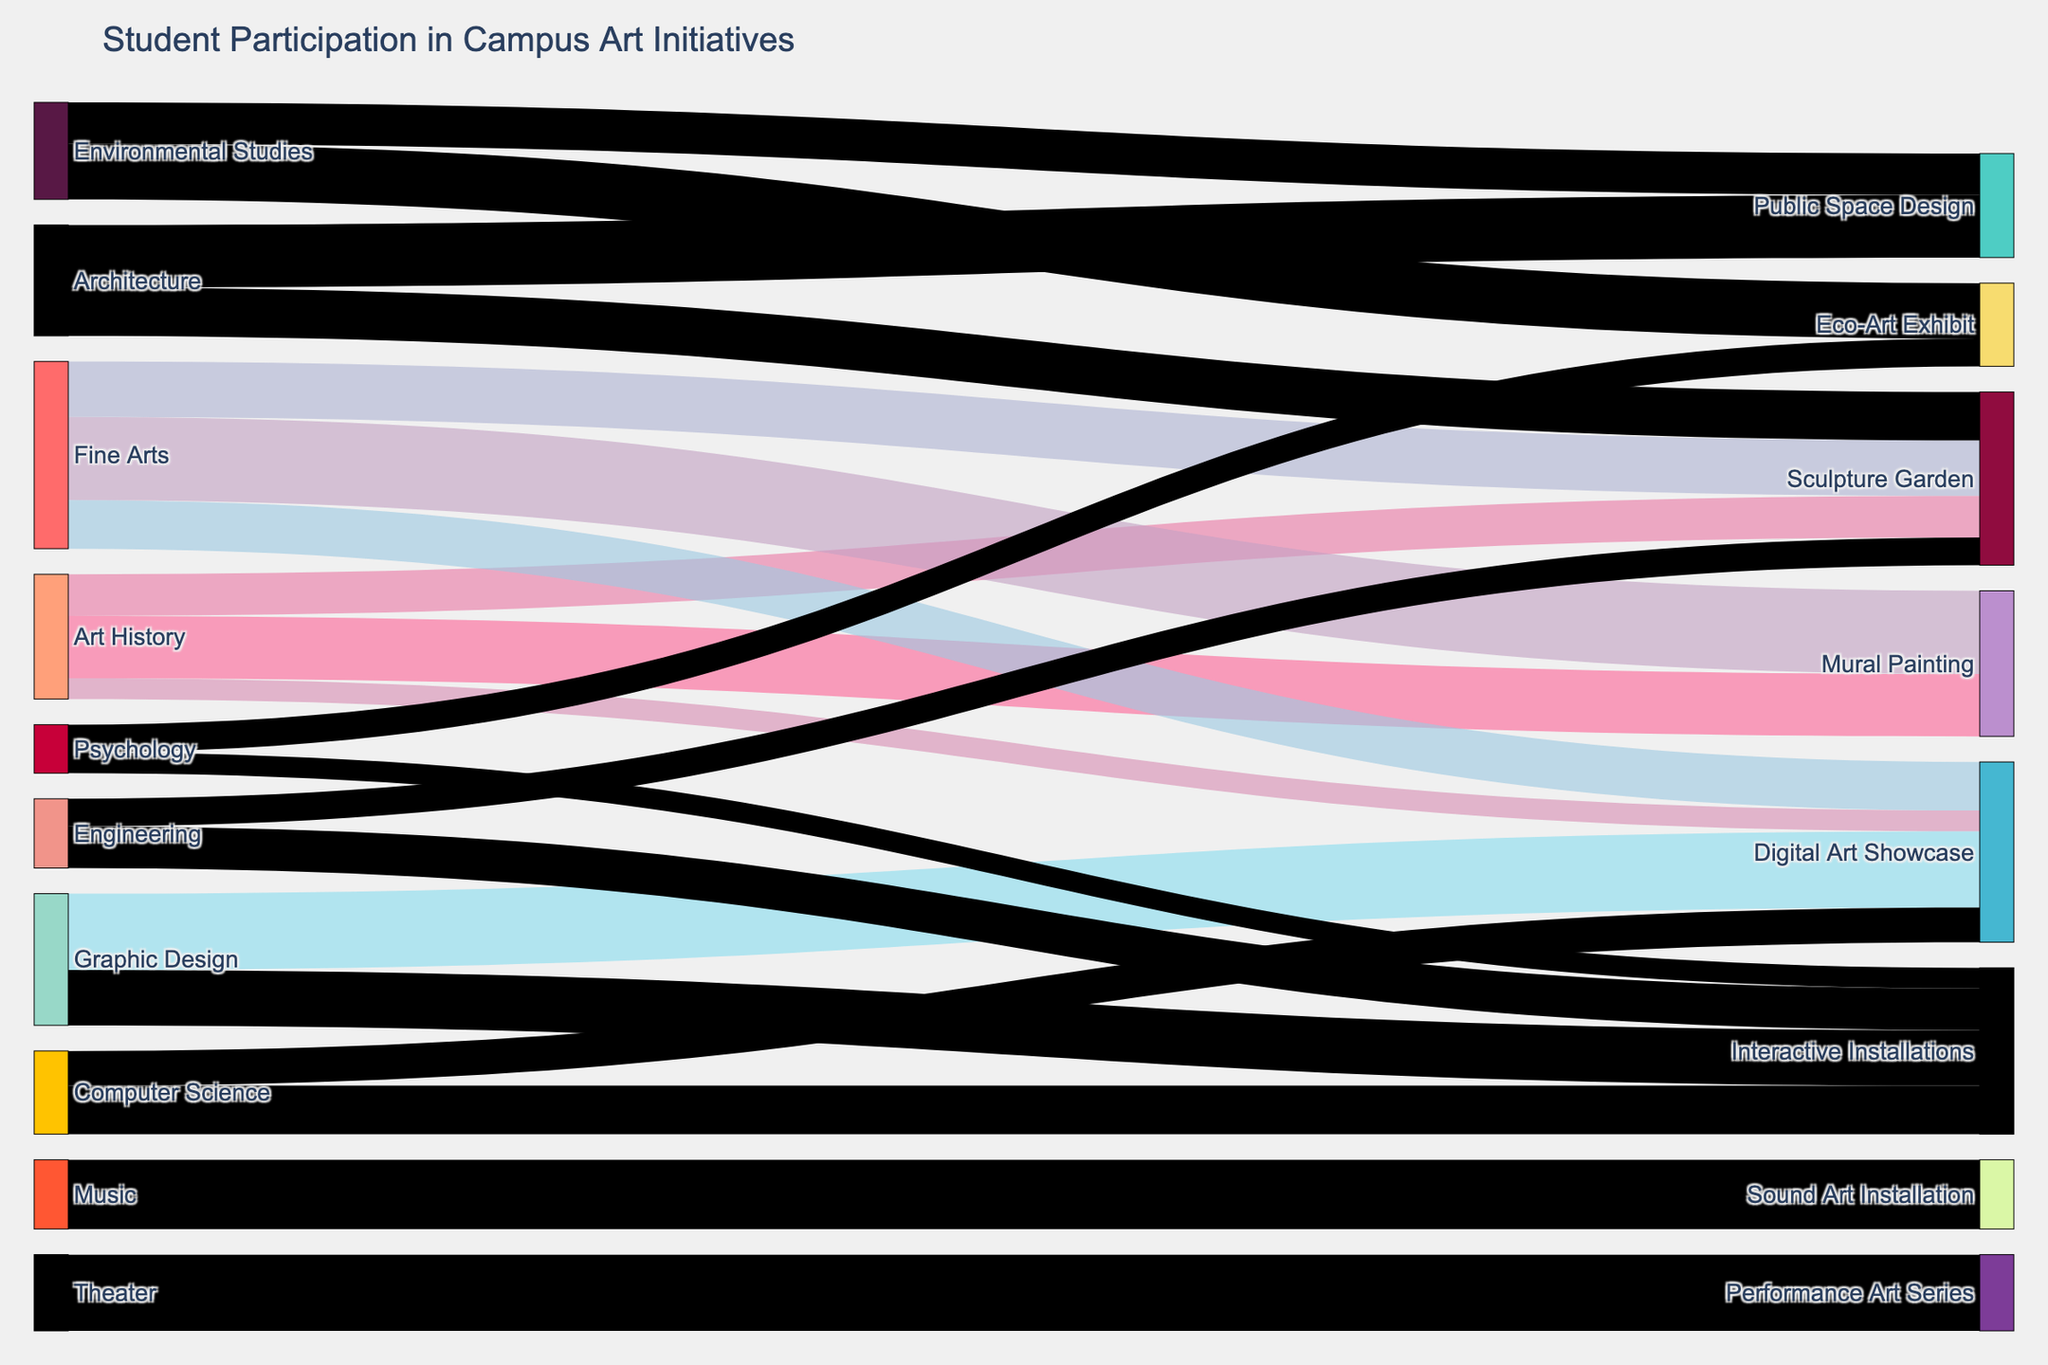what is the title of the figure? The title of the figure is usually displayed at the top of the plot and provides a summary of what the diagram represents. The title in this case states the overall theme of the Sankey diagram.
Answer: Student Participation in Campus Art Initiatives How many students from the Psychology major participated in Interactive Installations? To find the number of students, locate the flow from the "Psychology" node to the "Interactive Installations" node. The value associated with this flow is the number of students.
Answer: 15 Which major has the highest number of students participating in the Sculpture Garden? Check the flows directed towards the "Sculpture Garden" from various source majors. The flow with the highest value indicates the major with the most students participating. Compare the values to determine the highest.
Answer: Fine Arts What is the total number of students from Environmental Studies participating in Public Space Design and Eco-Art Exhibit? Sum the values of the flows from "Environmental Studies" to "Public Space Design" and "Eco-Art Exhibit". The value for "Public Space Design" is 30, and for "Eco-Art Exhibit" it is 40. Summing these gives the total: 30 + 40 = 70.
Answer: 70 Which art program has contributions from the most diverse set of majors? To determine this, count the number of different source nodes leading to each target node. The target node with the highest number of incoming distinct sources has the most diverse contributions.
Answer: Sculpture Garden Are more students from the Fine Arts or Graphic Design major involved in the Digital Art Showcase? Compare the flow values leading from "Fine Arts" and "Graphic Design" to "Digital Art Showcase". Fine Arts has 35 students, while Graphic Design has 55.
Answer: Graphic Design What percentage of Art History students participated in Mural Painting relative to all Art History students in the displayed art programs? First, find the total number of Art History students involved (sum values leading from Art History: 45 + 30 + 15 = 90). Then, calculate the percentage participating in Mural Painting: (45 / 90) * 100%.
Answer: 50% How many majors contribute to Interactive Installations, and how many students do they collectively bring? Count the distinct source nodes leading to "Interactive Installations", which are "Graphic Design", "Computer Science", "Engineering", and "Psychology". Calculate the total students by summing corresponding values: 40 + 35 + 30 + 15.
Answer: Four majors, 120 students What is the combined flow of students from Architecture and Environmental Studies into Public Space Design? Sum the values of the flows from "Architecture" and "Environmental Studies" to "Public Space Design". These values are 45 (Architecture) and 30 (Environmental Studies), giving a total of 45 + 30.
Answer: 75 students Which major shows the most even distribution across different art programs? Evaluate the distribution by checking the diversity and balance of flow values from each major to its associated target nodes. The goal is to identify which major has values that are close in number to each other.
Answer: Art History 